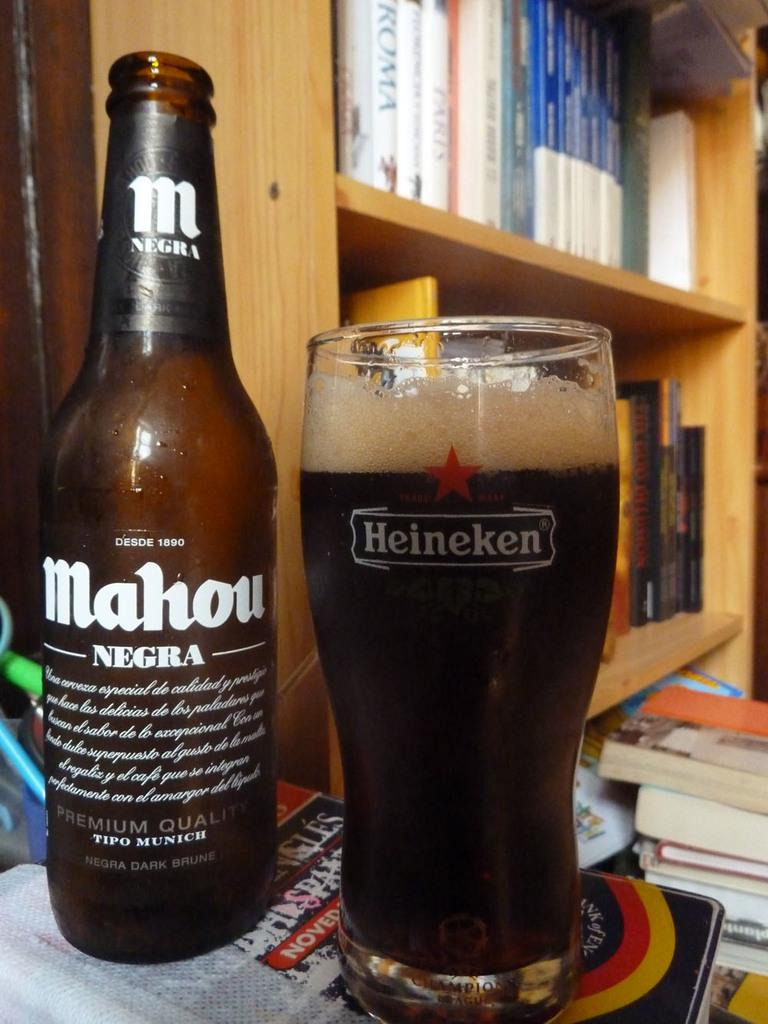<image>
Present a compact description of the photo's key features. A bottle of Mahou Negra is next to a Heineken glass filled with the beer. 